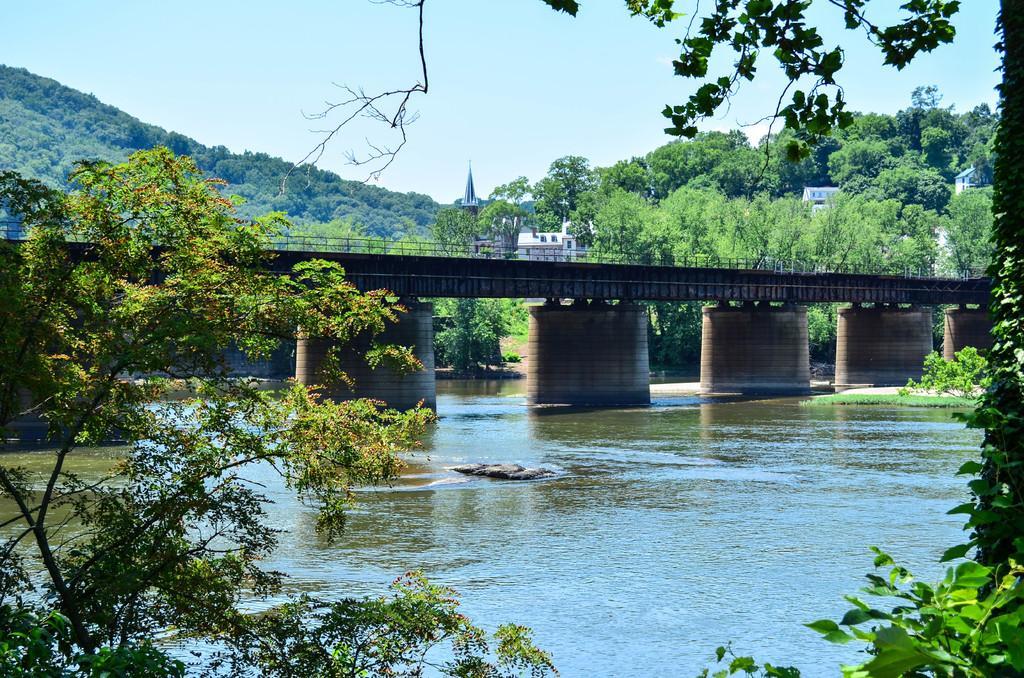Can you describe this image briefly? In this image we can see a bridge placed in water. On the right side of the image we can see trees and buildings. In the background, we can see a group of trees and sky. 